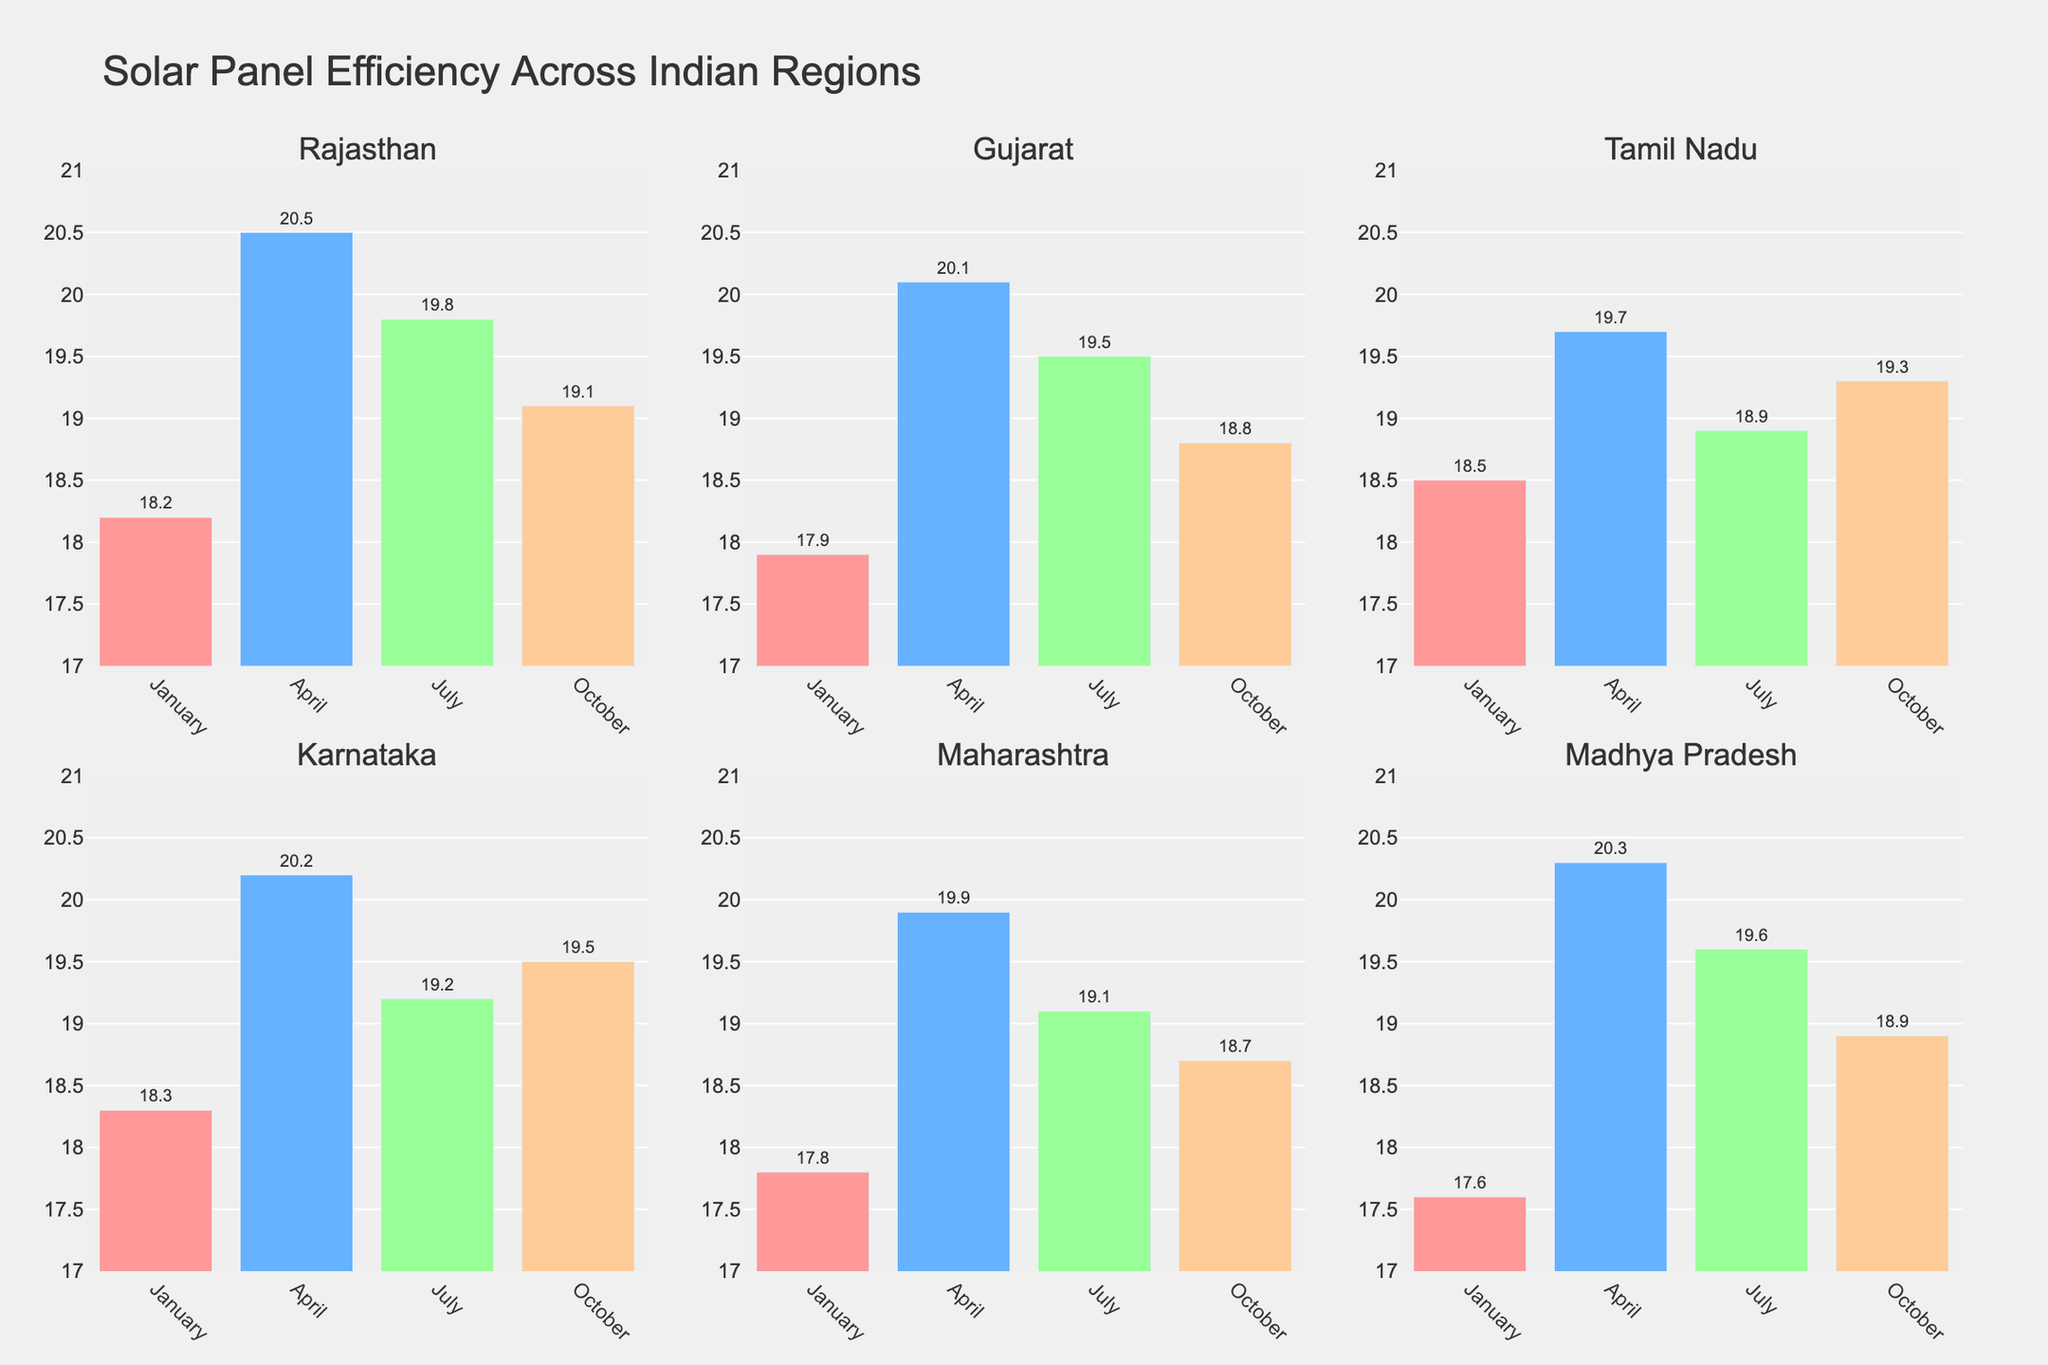What is the title of the plot? The title is located at the top of the plot, indicating the main topic or focus of the visualization. By referring to the figure, the title is specified in a prominent place.
Answer: Distribution of Attack Success Rates for Different Offensive Plays How many types of attacks are compared in the plot? The number of attack types can be identified by counting the distinct subplot titles along the vertical axis. Each title represents a different type of attack.
Answer: 5 Which play type has the lowest rate for a Quick Attack? Within the subplot for Quick Attack, locate the bar segment with the smallest value. This segment, along with its corresponding label, indicates the play type with the lowest rate.
Answer: Blocked How does the error rate for Back Row Attack compare to Slide Attack? Compare the error rate bars in both the Back Row Attack and Slide Attack subplots. By visually inspecting, you can determine which one is higher.
Answer: Back Row Attack has a higher error rate than Slide Attack What is the combined rate of Perfect Kill and Successful Attack for Pipe Attack? Locate the rates of Perfect Kill and Successful Attack for Pipe Attack subplot, then sum these two values to get the combined rate.
Answer: 0.67 Which attack type shows the most balanced distribution among all play types? Assess each attack type's subplot by visually checking how evenly the rates are distributed across different play types. The most balanced one will have bars that are relatively uniform in height.
Answer: Outside Attack For the Outside Attack, what is the sum of the Blocked and Error rates? Identify the rates assigned to Blocked and Error for Outside Attack. Sum these two rates to find the total.
Answer: 0.31 Which attack type has the highest rate of Successful Attack, and what is that rate? Look for the instance where the Successful Attack bar has the highest value among all subplots. Note the corresponding attack type and rate.
Answer: Slide Attack, 0.31 What percentage of Quick Attacks result in an error? Refer to the exact value of the Error rate segment within the Quick Attack subplot and translate this into a percentage.
Answer: 15% Compare the Perfect Kill rates between Quick Attack and Outside Attack. Which one is higher, and by how much? Look at the Perfect Kill rate bars for Quick Attack and Outside Attack subplots. Determine the difference between the two values to establish which is higher and by what amount.
Answer: Quick Attack is higher by 0.03 